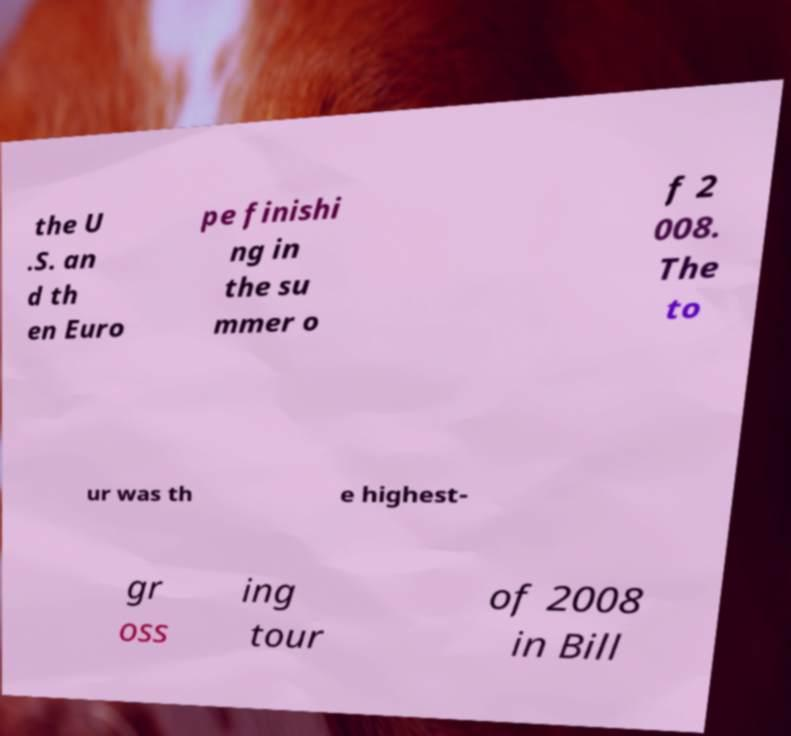Could you extract and type out the text from this image? the U .S. an d th en Euro pe finishi ng in the su mmer o f 2 008. The to ur was th e highest- gr oss ing tour of 2008 in Bill 